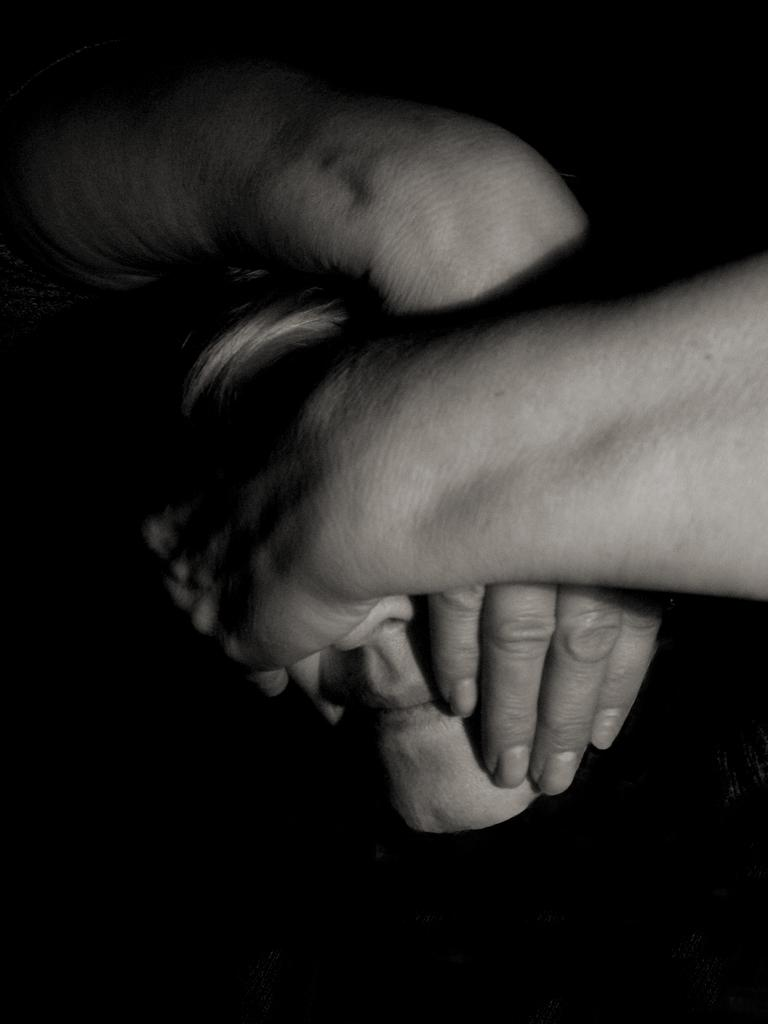What is the main subject in the foreground of the image? There is a person's face in the foreground of the image. What is covering the person's face in the image? The person's face is covered by two hands. Whose hands are covering the person's face? The hands belong to another person. What type of sign can be seen in the image? There is no sign present in the image; it features a person's face covered by two hands. How many clams are visible in the image? There are no clams present in the image. 